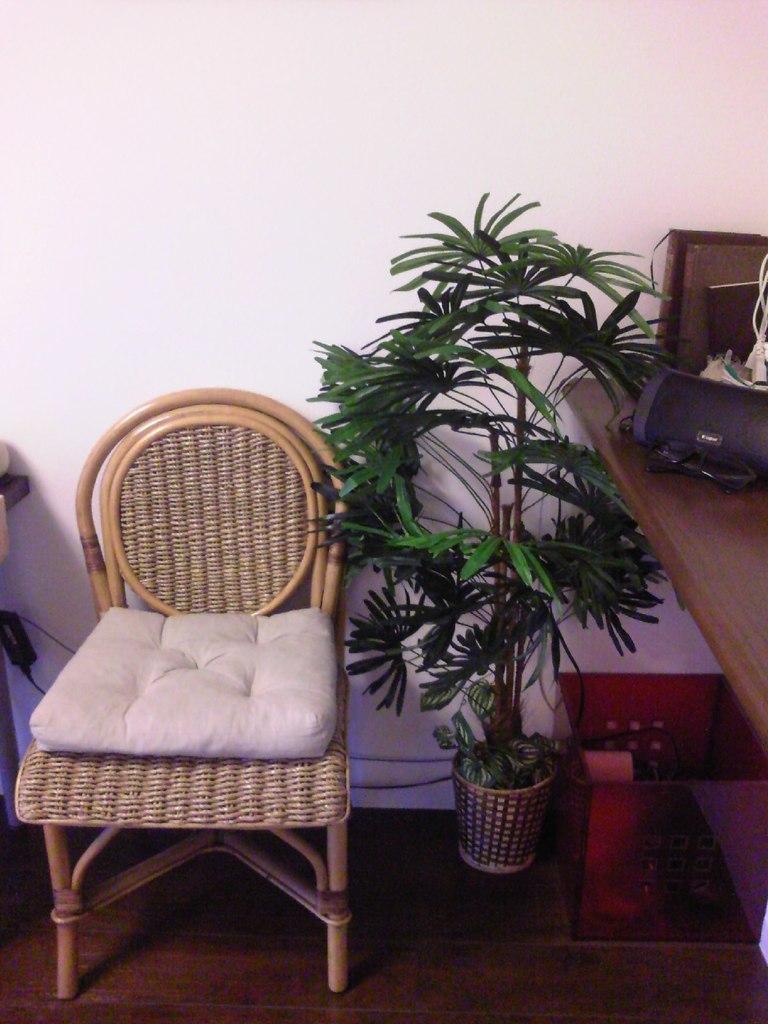In one or two sentences, can you explain what this image depicts? We can able to see a chair, plant, container and table. This chair is with pillow. On this table there are things. 